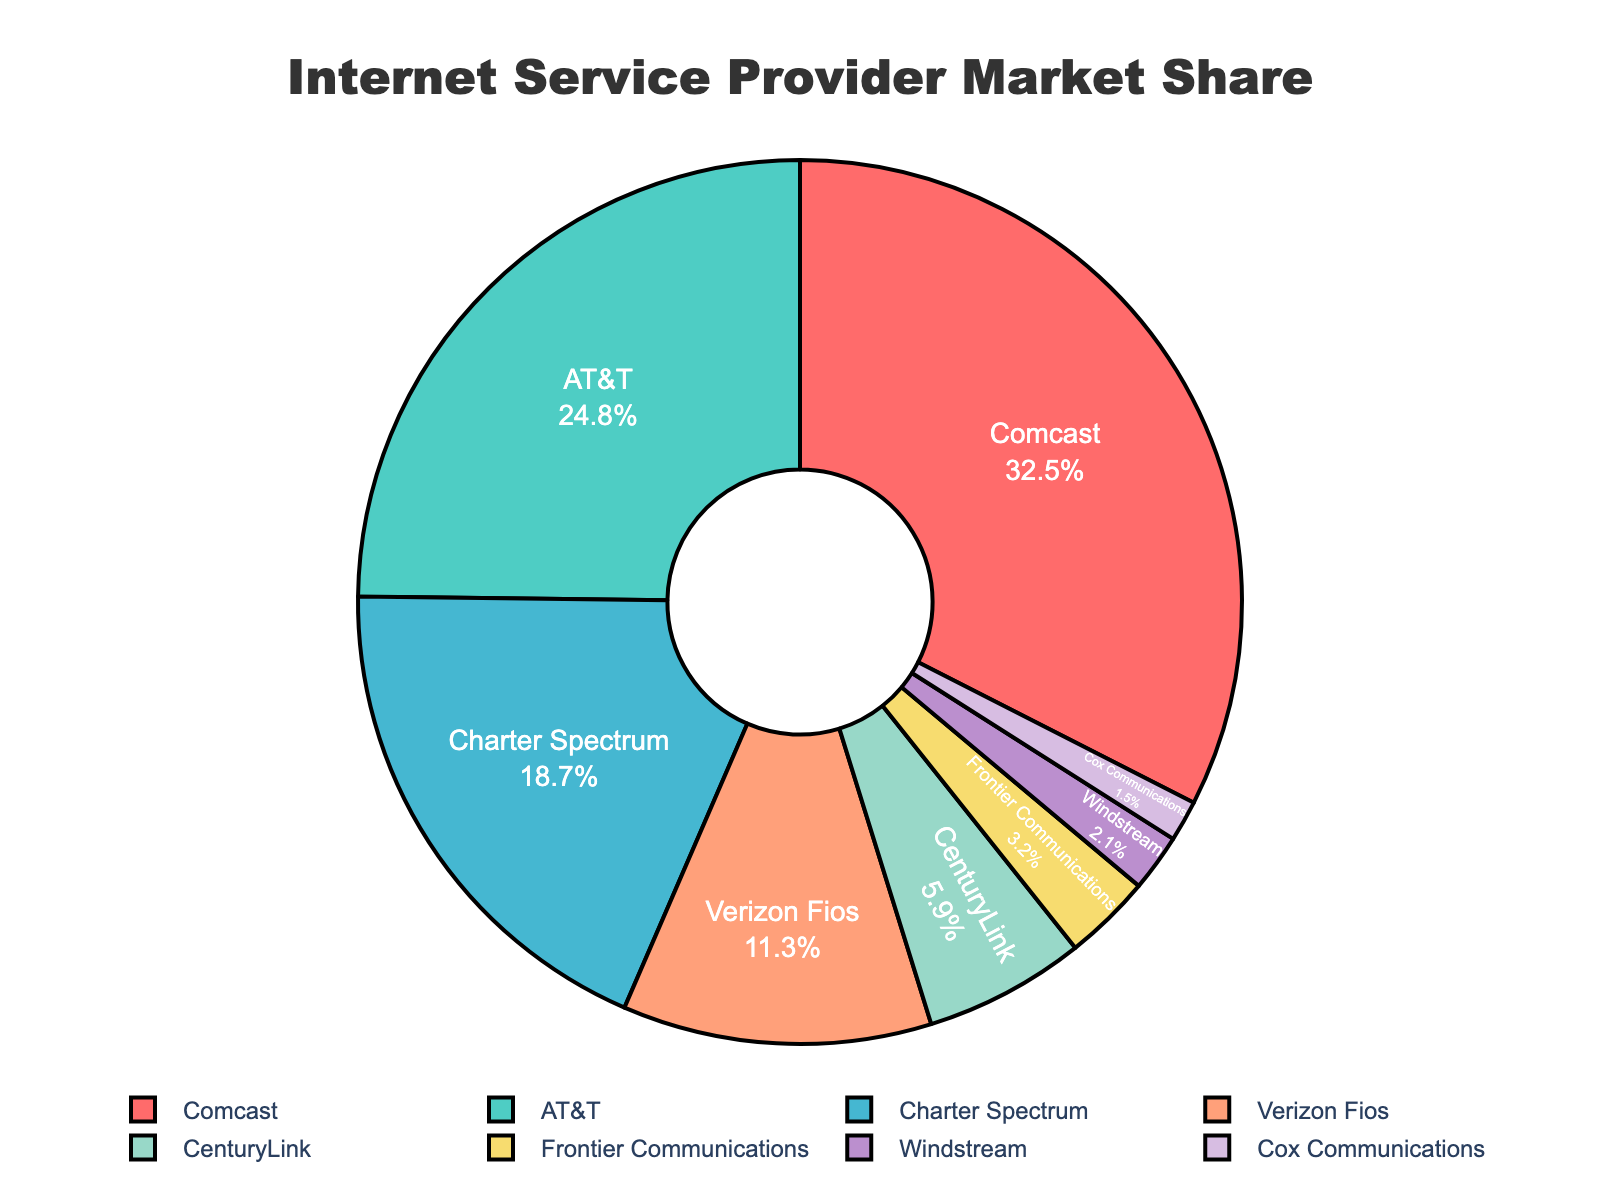What is the market share percentage of Comcast? The market share percentage can be directly seen from the pie chart where Comcast is labeled. Comcast's market share is shown as 32.5%.
Answer: 32.5% Which ISP has the second-largest market share? By comparing the sizes of the pie sections and looking at their labels, the second-largest market share after Comcast (32.5%) is AT&T with a share of 24.8%.
Answer: AT&T What is the combined market share percentage of Verizon Fios and CenturyLink? To find the combined market share, you add the individual percentages of Verizon Fios and CenturyLink. Verizon Fios has a market share of 11.3%, and CenturyLink has 5.9%. Therefore, 11.3% + 5.9% = 17.2%.
Answer: 17.2% What is the difference in market share between Comcast and Charter Spectrum? Subtract the market share of Charter Spectrum from that of Comcast. Comcast has 32.5%, and Charter Spectrum has 18.7%. The difference is 32.5% - 18.7% = 13.8%.
Answer: 13.8% Which ISPs have a market share of less than 5%? By examining the pie chart, we can identify the ISPs with a market share of less than 5%. These are CenturyLink (5.9%) which is slightly above 5%, and the ISPs below this threshold are Frontier Communications (3.2%), Windstream (2.1%), and Cox Communications (1.5%).
Answer: Frontier Communications, Windstream, Cox Communications What is the sum of the market shares of Frontier Communications, Windstream, and Cox Communications? Add the percentages of Frontier Communications (3.2%), Windstream (2.1%), and Cox Communications (1.5%). The total is 3.2% + 2.1% + 1.5% = 6.8%.
Answer: 6.8% Compared to CenturyLink, does Verizon Fios have a higher or lower market share? By examining their market share percentages on the pie chart, Verizon Fios has 11.3%, and CenturyLink has 5.9%. Verizon Fios has a higher market share.
Answer: Higher What percentage of the market do the top three ISPs control? The top three ISPs by market share are Comcast (32.5%), AT&T (24.8%), and Charter Spectrum (18.7%). Together, their combined market share is 32.5% + 24.8% + 18.7% = 76%.
Answer: 76% What is the average market share of Comcast, AT&T, and Charter Spectrum? First, find the total market share combined (32.5% + 24.8% + 18.7% = 76%), then divide by the number of ISPs (3). The average market share is 76% / 3 = 25.33%.
Answer: 25.33% 